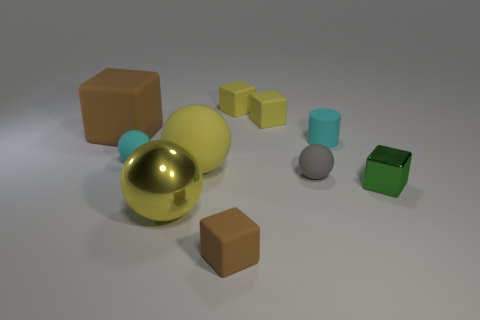Is there anything else that has the same material as the tiny gray ball?
Keep it short and to the point. Yes. Is the number of tiny rubber things to the right of the big yellow shiny sphere greater than the number of small green blocks?
Your answer should be very brief. Yes. How many matte objects are in front of the block that is on the left side of the tiny cube that is in front of the green thing?
Make the answer very short. 5. There is a brown rubber cube on the right side of the large brown thing; is it the same size as the yellow sphere that is behind the tiny green metallic block?
Your answer should be very brief. No. There is a tiny cyan object that is to the left of the brown block that is in front of the tiny green cube; what is its material?
Make the answer very short. Rubber. How many objects are cubes that are behind the yellow metal sphere or tiny brown rubber balls?
Make the answer very short. 4. Is the number of small cyan cylinders behind the cylinder the same as the number of large rubber things that are to the right of the gray object?
Offer a terse response. Yes. There is a brown thing that is in front of the matte cube left of the rubber object in front of the big yellow shiny sphere; what is its material?
Offer a very short reply. Rubber. What size is the thing that is both left of the big yellow matte object and in front of the big yellow rubber ball?
Your answer should be very brief. Large. Is the shape of the green object the same as the small brown thing?
Your answer should be compact. Yes. 